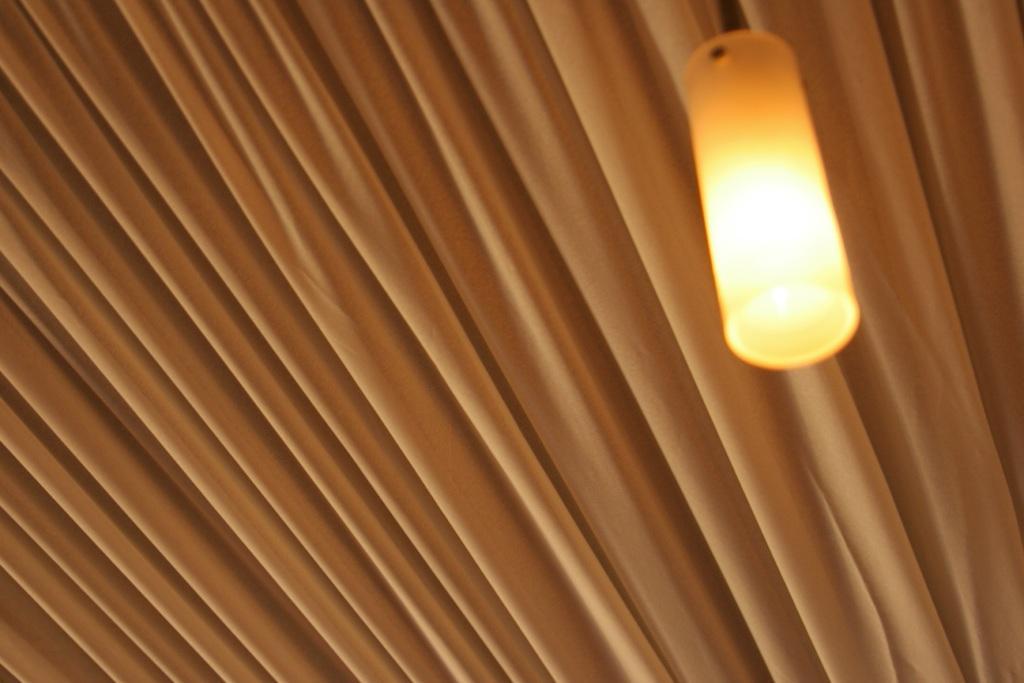In one or two sentences, can you explain what this image depicts? In this image we can see curtain and a lamp. 